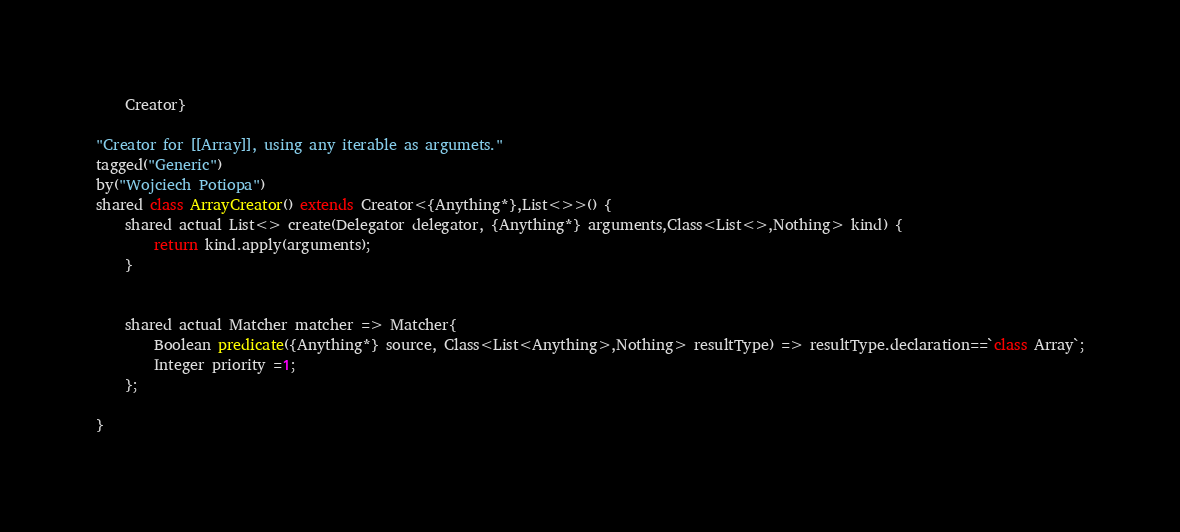Convert code to text. <code><loc_0><loc_0><loc_500><loc_500><_Ceylon_>	Creator}

"Creator for [[Array]], using any iterable as argumets."
tagged("Generic")
by("Wojciech Potiopa")
shared class ArrayCreator() extends Creator<{Anything*},List<>>() {
	shared actual List<> create(Delegator delegator, {Anything*} arguments,Class<List<>,Nothing> kind) {
		return kind.apply(arguments);
	}
	
	
	shared actual Matcher matcher => Matcher{
		Boolean predicate({Anything*} source, Class<List<Anything>,Nothing> resultType) => resultType.declaration==`class Array`;
		Integer priority =1;
	};
	
}

</code> 